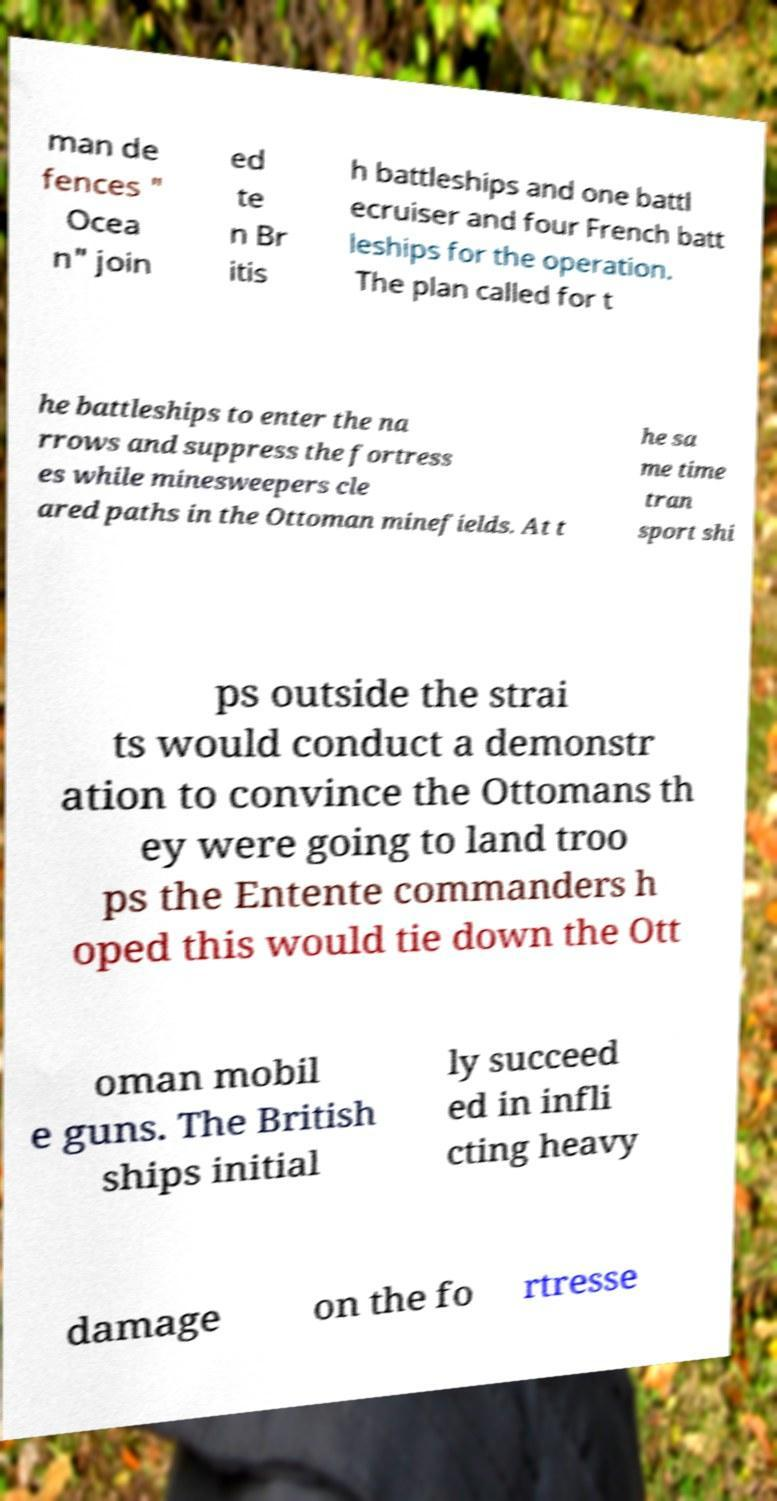Can you read and provide the text displayed in the image?This photo seems to have some interesting text. Can you extract and type it out for me? man de fences " Ocea n" join ed te n Br itis h battleships and one battl ecruiser and four French batt leships for the operation. The plan called for t he battleships to enter the na rrows and suppress the fortress es while minesweepers cle ared paths in the Ottoman minefields. At t he sa me time tran sport shi ps outside the strai ts would conduct a demonstr ation to convince the Ottomans th ey were going to land troo ps the Entente commanders h oped this would tie down the Ott oman mobil e guns. The British ships initial ly succeed ed in infli cting heavy damage on the fo rtresse 